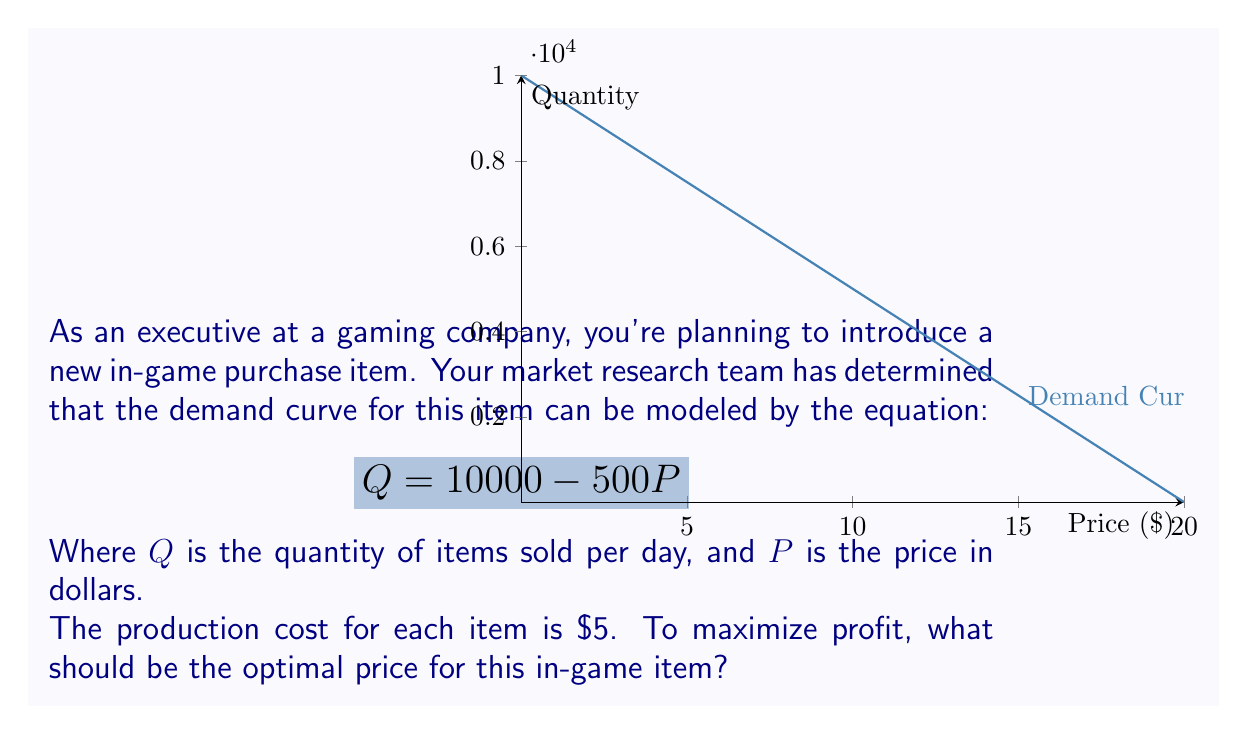Give your solution to this math problem. Let's approach this step-by-step:

1) The profit function is given by:
   $$\text{Profit} = \text{Revenue} - \text{Cost}$$

2) Revenue is price times quantity:
   $$\text{Revenue} = P \cdot Q = P \cdot (10000 - 500P) = 10000P - 500P^2$$

3) Cost is $5 per item:
   $$\text{Cost} = 5Q = 5(10000 - 500P) = 50000 - 2500P$$

4) Therefore, the profit function is:
   $$\text{Profit} = (10000P - 500P^2) - (50000 - 2500P)$$
   $$\text{Profit} = -500P^2 + 12500P - 50000$$

5) To find the maximum profit, we differentiate the profit function with respect to P and set it to zero:
   $$\frac{d(\text{Profit})}{dP} = -1000P + 12500 = 0$$

6) Solving this equation:
   $$-1000P = -12500$$
   $$P = 12.5$$

7) To confirm this is a maximum, we can check the second derivative:
   $$\frac{d^2(\text{Profit})}{dP^2} = -1000$$
   Which is negative, confirming a maximum.

8) Therefore, the optimal price is $12.50.
Answer: $12.50 